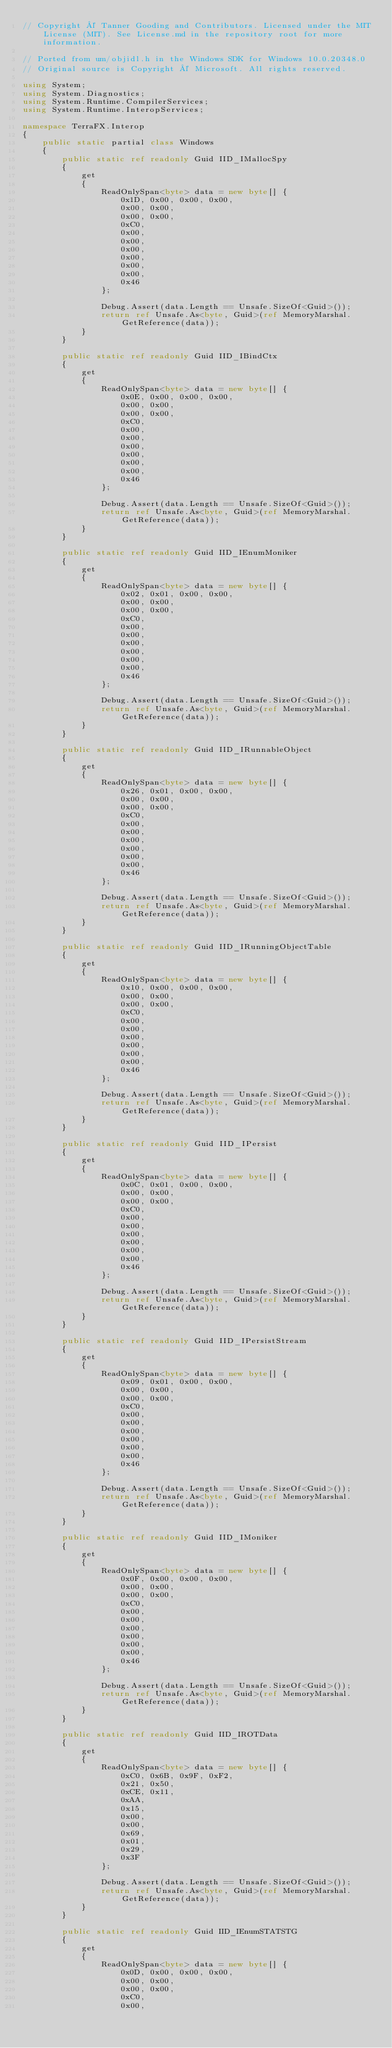<code> <loc_0><loc_0><loc_500><loc_500><_C#_>// Copyright © Tanner Gooding and Contributors. Licensed under the MIT License (MIT). See License.md in the repository root for more information.

// Ported from um/objidl.h in the Windows SDK for Windows 10.0.20348.0
// Original source is Copyright © Microsoft. All rights reserved.

using System;
using System.Diagnostics;
using System.Runtime.CompilerServices;
using System.Runtime.InteropServices;

namespace TerraFX.Interop
{
    public static partial class Windows
    {
        public static ref readonly Guid IID_IMallocSpy
        {
            get
            {
                ReadOnlySpan<byte> data = new byte[] {
                    0x1D, 0x00, 0x00, 0x00,
                    0x00, 0x00,
                    0x00, 0x00,
                    0xC0,
                    0x00,
                    0x00,
                    0x00,
                    0x00,
                    0x00,
                    0x00,
                    0x46
                };

                Debug.Assert(data.Length == Unsafe.SizeOf<Guid>());
                return ref Unsafe.As<byte, Guid>(ref MemoryMarshal.GetReference(data));
            }
        }

        public static ref readonly Guid IID_IBindCtx
        {
            get
            {
                ReadOnlySpan<byte> data = new byte[] {
                    0x0E, 0x00, 0x00, 0x00,
                    0x00, 0x00,
                    0x00, 0x00,
                    0xC0,
                    0x00,
                    0x00,
                    0x00,
                    0x00,
                    0x00,
                    0x00,
                    0x46
                };

                Debug.Assert(data.Length == Unsafe.SizeOf<Guid>());
                return ref Unsafe.As<byte, Guid>(ref MemoryMarshal.GetReference(data));
            }
        }

        public static ref readonly Guid IID_IEnumMoniker
        {
            get
            {
                ReadOnlySpan<byte> data = new byte[] {
                    0x02, 0x01, 0x00, 0x00,
                    0x00, 0x00,
                    0x00, 0x00,
                    0xC0,
                    0x00,
                    0x00,
                    0x00,
                    0x00,
                    0x00,
                    0x00,
                    0x46
                };

                Debug.Assert(data.Length == Unsafe.SizeOf<Guid>());
                return ref Unsafe.As<byte, Guid>(ref MemoryMarshal.GetReference(data));
            }
        }

        public static ref readonly Guid IID_IRunnableObject
        {
            get
            {
                ReadOnlySpan<byte> data = new byte[] {
                    0x26, 0x01, 0x00, 0x00,
                    0x00, 0x00,
                    0x00, 0x00,
                    0xC0,
                    0x00,
                    0x00,
                    0x00,
                    0x00,
                    0x00,
                    0x00,
                    0x46
                };

                Debug.Assert(data.Length == Unsafe.SizeOf<Guid>());
                return ref Unsafe.As<byte, Guid>(ref MemoryMarshal.GetReference(data));
            }
        }

        public static ref readonly Guid IID_IRunningObjectTable
        {
            get
            {
                ReadOnlySpan<byte> data = new byte[] {
                    0x10, 0x00, 0x00, 0x00,
                    0x00, 0x00,
                    0x00, 0x00,
                    0xC0,
                    0x00,
                    0x00,
                    0x00,
                    0x00,
                    0x00,
                    0x00,
                    0x46
                };

                Debug.Assert(data.Length == Unsafe.SizeOf<Guid>());
                return ref Unsafe.As<byte, Guid>(ref MemoryMarshal.GetReference(data));
            }
        }

        public static ref readonly Guid IID_IPersist
        {
            get
            {
                ReadOnlySpan<byte> data = new byte[] {
                    0x0C, 0x01, 0x00, 0x00,
                    0x00, 0x00,
                    0x00, 0x00,
                    0xC0,
                    0x00,
                    0x00,
                    0x00,
                    0x00,
                    0x00,
                    0x00,
                    0x46
                };

                Debug.Assert(data.Length == Unsafe.SizeOf<Guid>());
                return ref Unsafe.As<byte, Guid>(ref MemoryMarshal.GetReference(data));
            }
        }

        public static ref readonly Guid IID_IPersistStream
        {
            get
            {
                ReadOnlySpan<byte> data = new byte[] {
                    0x09, 0x01, 0x00, 0x00,
                    0x00, 0x00,
                    0x00, 0x00,
                    0xC0,
                    0x00,
                    0x00,
                    0x00,
                    0x00,
                    0x00,
                    0x00,
                    0x46
                };

                Debug.Assert(data.Length == Unsafe.SizeOf<Guid>());
                return ref Unsafe.As<byte, Guid>(ref MemoryMarshal.GetReference(data));
            }
        }

        public static ref readonly Guid IID_IMoniker
        {
            get
            {
                ReadOnlySpan<byte> data = new byte[] {
                    0x0F, 0x00, 0x00, 0x00,
                    0x00, 0x00,
                    0x00, 0x00,
                    0xC0,
                    0x00,
                    0x00,
                    0x00,
                    0x00,
                    0x00,
                    0x00,
                    0x46
                };

                Debug.Assert(data.Length == Unsafe.SizeOf<Guid>());
                return ref Unsafe.As<byte, Guid>(ref MemoryMarshal.GetReference(data));
            }
        }

        public static ref readonly Guid IID_IROTData
        {
            get
            {
                ReadOnlySpan<byte> data = new byte[] {
                    0xC0, 0x6B, 0x9F, 0xF2,
                    0x21, 0x50,
                    0xCE, 0x11,
                    0xAA,
                    0x15,
                    0x00,
                    0x00,
                    0x69,
                    0x01,
                    0x29,
                    0x3F
                };

                Debug.Assert(data.Length == Unsafe.SizeOf<Guid>());
                return ref Unsafe.As<byte, Guid>(ref MemoryMarshal.GetReference(data));
            }
        }

        public static ref readonly Guid IID_IEnumSTATSTG
        {
            get
            {
                ReadOnlySpan<byte> data = new byte[] {
                    0x0D, 0x00, 0x00, 0x00,
                    0x00, 0x00,
                    0x00, 0x00,
                    0xC0,
                    0x00,</code> 